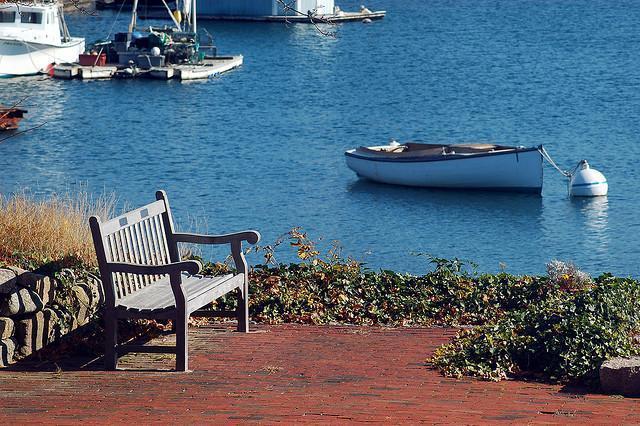How many people are on the bench?
Give a very brief answer. 0. How many boats are there?
Give a very brief answer. 3. 